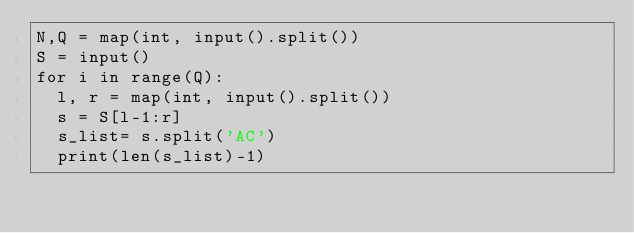<code> <loc_0><loc_0><loc_500><loc_500><_Python_>N,Q = map(int, input().split())
S = input()
for i in range(Q):
  l, r = map(int, input().split())
  s = S[l-1:r]
  s_list= s.split('AC')
  print(len(s_list)-1)</code> 